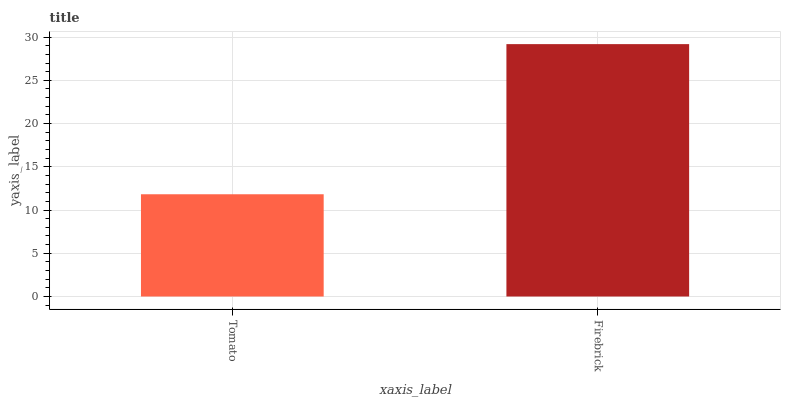Is Tomato the minimum?
Answer yes or no. Yes. Is Firebrick the maximum?
Answer yes or no. Yes. Is Firebrick the minimum?
Answer yes or no. No. Is Firebrick greater than Tomato?
Answer yes or no. Yes. Is Tomato less than Firebrick?
Answer yes or no. Yes. Is Tomato greater than Firebrick?
Answer yes or no. No. Is Firebrick less than Tomato?
Answer yes or no. No. Is Firebrick the high median?
Answer yes or no. Yes. Is Tomato the low median?
Answer yes or no. Yes. Is Tomato the high median?
Answer yes or no. No. Is Firebrick the low median?
Answer yes or no. No. 